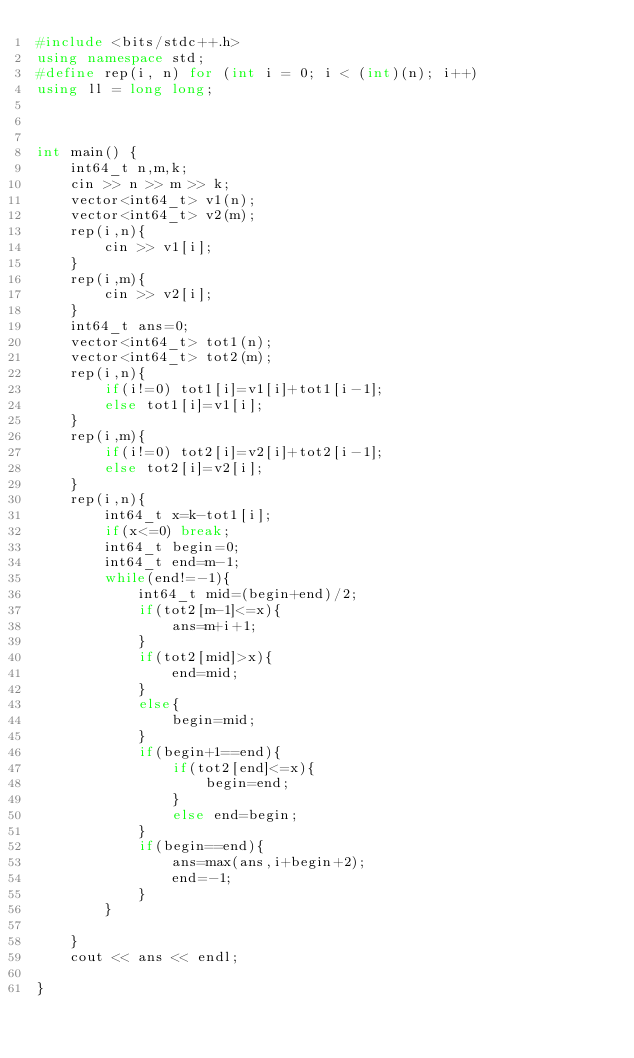Convert code to text. <code><loc_0><loc_0><loc_500><loc_500><_C++_>#include <bits/stdc++.h>
using namespace std;
#define rep(i, n) for (int i = 0; i < (int)(n); i++)
using ll = long long;



int main() {
    int64_t n,m,k;
    cin >> n >> m >> k;
    vector<int64_t> v1(n);
    vector<int64_t> v2(m);
    rep(i,n){
        cin >> v1[i];
    }
    rep(i,m){
        cin >> v2[i];
    }
    int64_t ans=0;
    vector<int64_t> tot1(n);
    vector<int64_t> tot2(m);
    rep(i,n){
        if(i!=0) tot1[i]=v1[i]+tot1[i-1];
        else tot1[i]=v1[i];
    }
    rep(i,m){
        if(i!=0) tot2[i]=v2[i]+tot2[i-1];
        else tot2[i]=v2[i];
    }
    rep(i,n){
        int64_t x=k-tot1[i];
        if(x<=0) break;
        int64_t begin=0;
        int64_t end=m-1;
        while(end!=-1){
            int64_t mid=(begin+end)/2;
            if(tot2[m-1]<=x){
                ans=m+i+1;
            }
            if(tot2[mid]>x){
                end=mid;
            }
            else{
                begin=mid;
            }
            if(begin+1==end){
                if(tot2[end]<=x){
                    begin=end;
                }
                else end=begin;
            }
            if(begin==end){
                ans=max(ans,i+begin+2);
                end=-1;
            }
        }
        
    }
    cout << ans << endl;
    
}</code> 